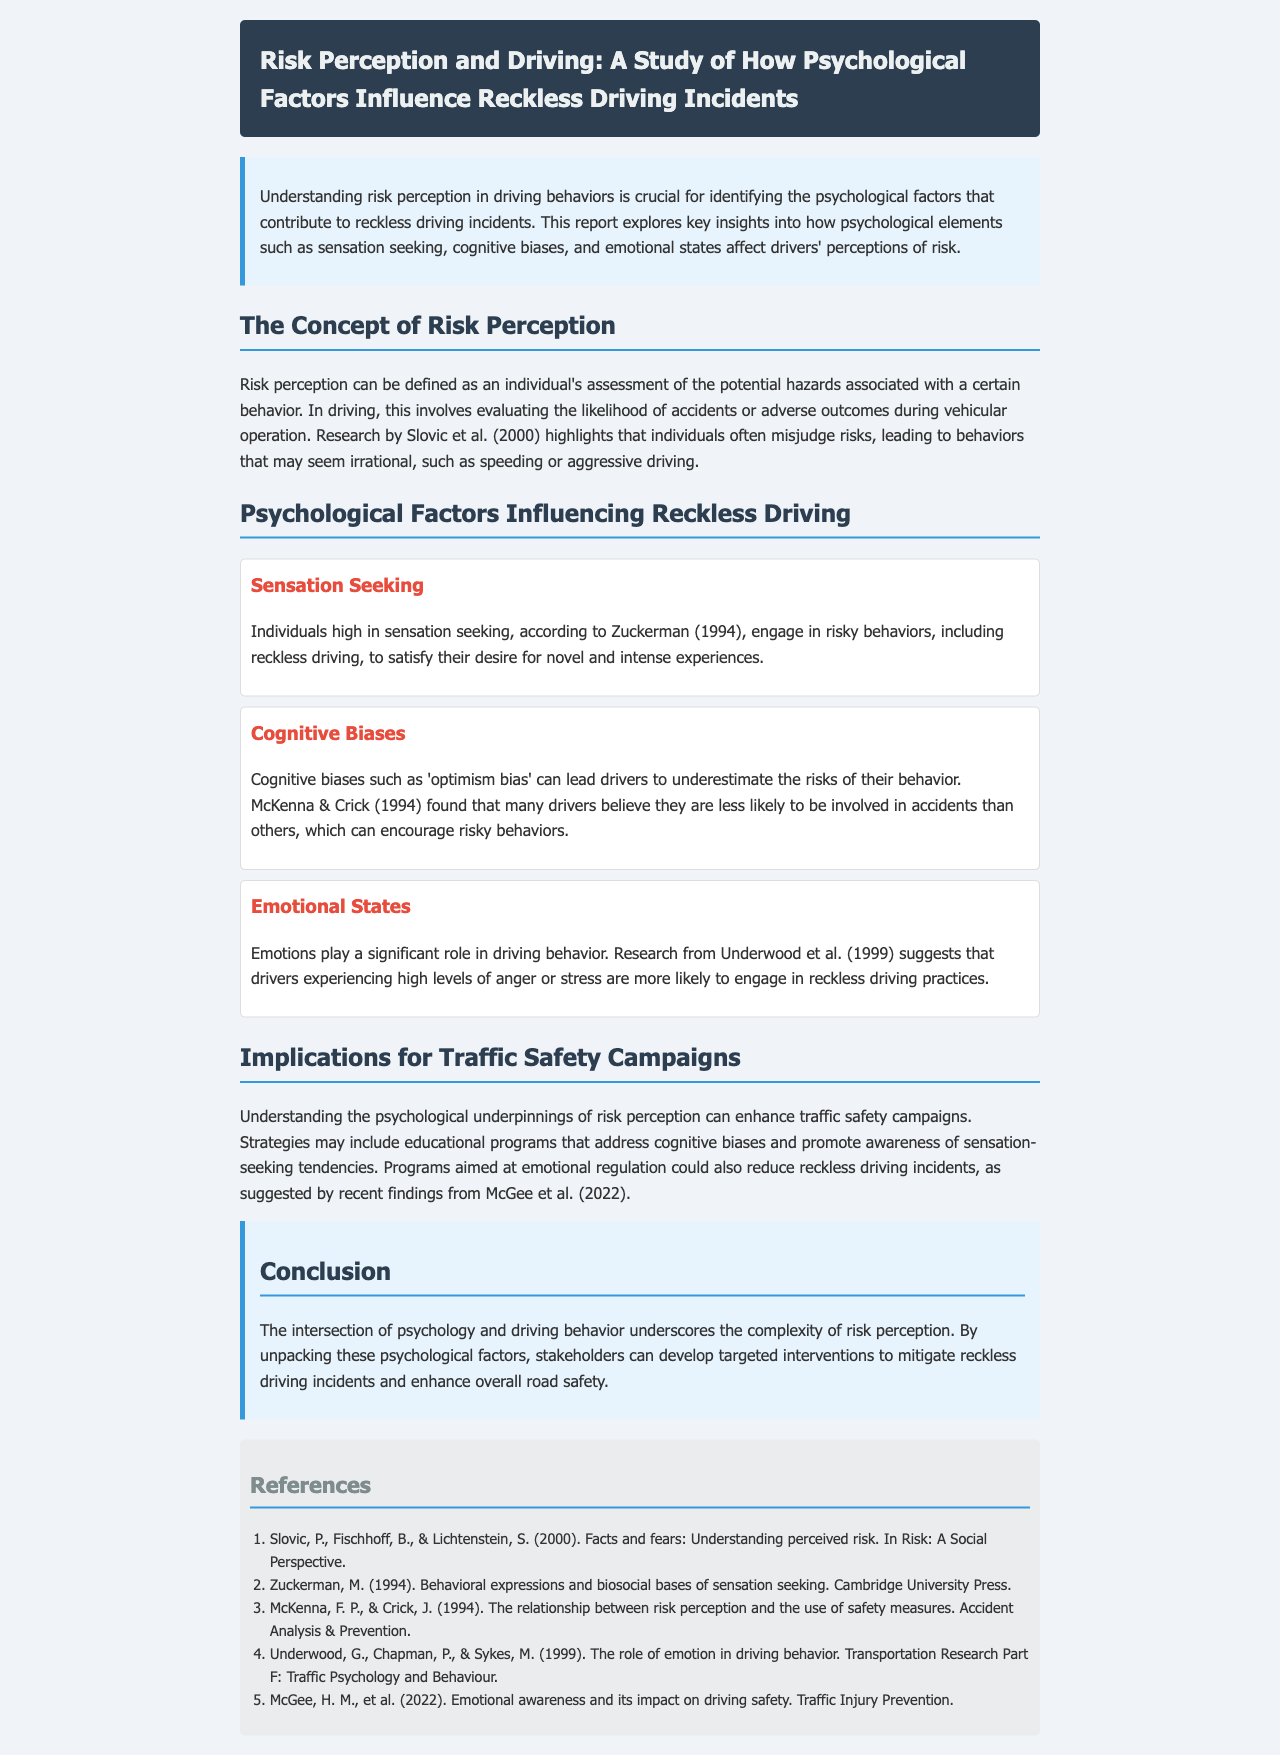What is the title of the report? The title is a key component of the document that encapsulates the main topic, which is provided at the beginning.
Answer: Risk Perception and Driving: A Study of How Psychological Factors Influence Reckless Driving Incidents Who conducted research highlighting misjudged risks in driving? The research by Slovic et al. is mentioned as pivotal in illustrating the misjudgment of risks in driving.
Answer: Slovic et al What psychological factor is related to engaging in risky behaviors for novel experiences? This question refers to a specific psychological element discussed in the report that contributes to reckless driving incidents.
Answer: Sensation Seeking Which cognitive bias leads drivers to underestimate risks? The report identifies a specific cognitive bias that affects drivers' perceptions of risk, which is relevant to reckless driving.
Answer: Optimism bias What emotional state increases the likelihood of reckless driving? This question asks for a specific emotional condition that is discussed in the study regarding its impact on driving behavior.
Answer: Anger What year is associated with the research on emotional awareness impacting driving safety? This refers to specific findings in the report that are associated with a particular publication year.
Answer: 2022 What key strategies should traffic safety campaigns include? This question seeks to encapsulate the suggested interventions discussed in the implications section of the report.
Answer: Educational programs What is the main implication of understanding psychological factors in driving? This question focuses on the overarching significance highlighted in the report regarding the understanding of psychological elements in the context of driving behavior.
Answer: Targeted interventions 